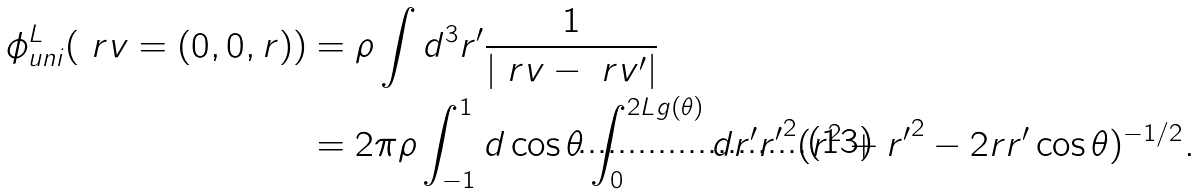<formula> <loc_0><loc_0><loc_500><loc_500>\phi _ { u n i } ^ { L } ( \ r v = ( 0 , 0 , r ) ) & = \rho \int d ^ { 3 } r ^ { \prime } \frac { 1 } { | \ r v - \ r v ^ { \prime } | } \\ & = 2 \pi \rho \int _ { - 1 } ^ { 1 } d \cos \theta \int _ { 0 } ^ { 2 L g ( \theta ) } d r ^ { \prime } { r ^ { \prime } } ^ { 2 } ( r ^ { 2 } + { r ^ { \prime } } ^ { 2 } - 2 r r ^ { \prime } \cos \theta ) ^ { - 1 / 2 } .</formula> 